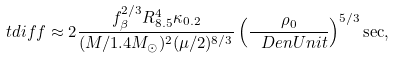Convert formula to latex. <formula><loc_0><loc_0><loc_500><loc_500>\ t d i f f \approx 2 \frac { f _ { \beta } ^ { 2 / 3 } R _ { 8 . 5 } ^ { 4 } \kappa _ { 0 . 2 } } { ( M / 1 . 4 M _ { \odot } ) ^ { 2 } ( \mu / 2 ) ^ { 8 / 3 } } \left ( \frac { \rho _ { 0 } } { \ D e n U n i t } \right ) ^ { 5 / 3 } \sec ,</formula> 